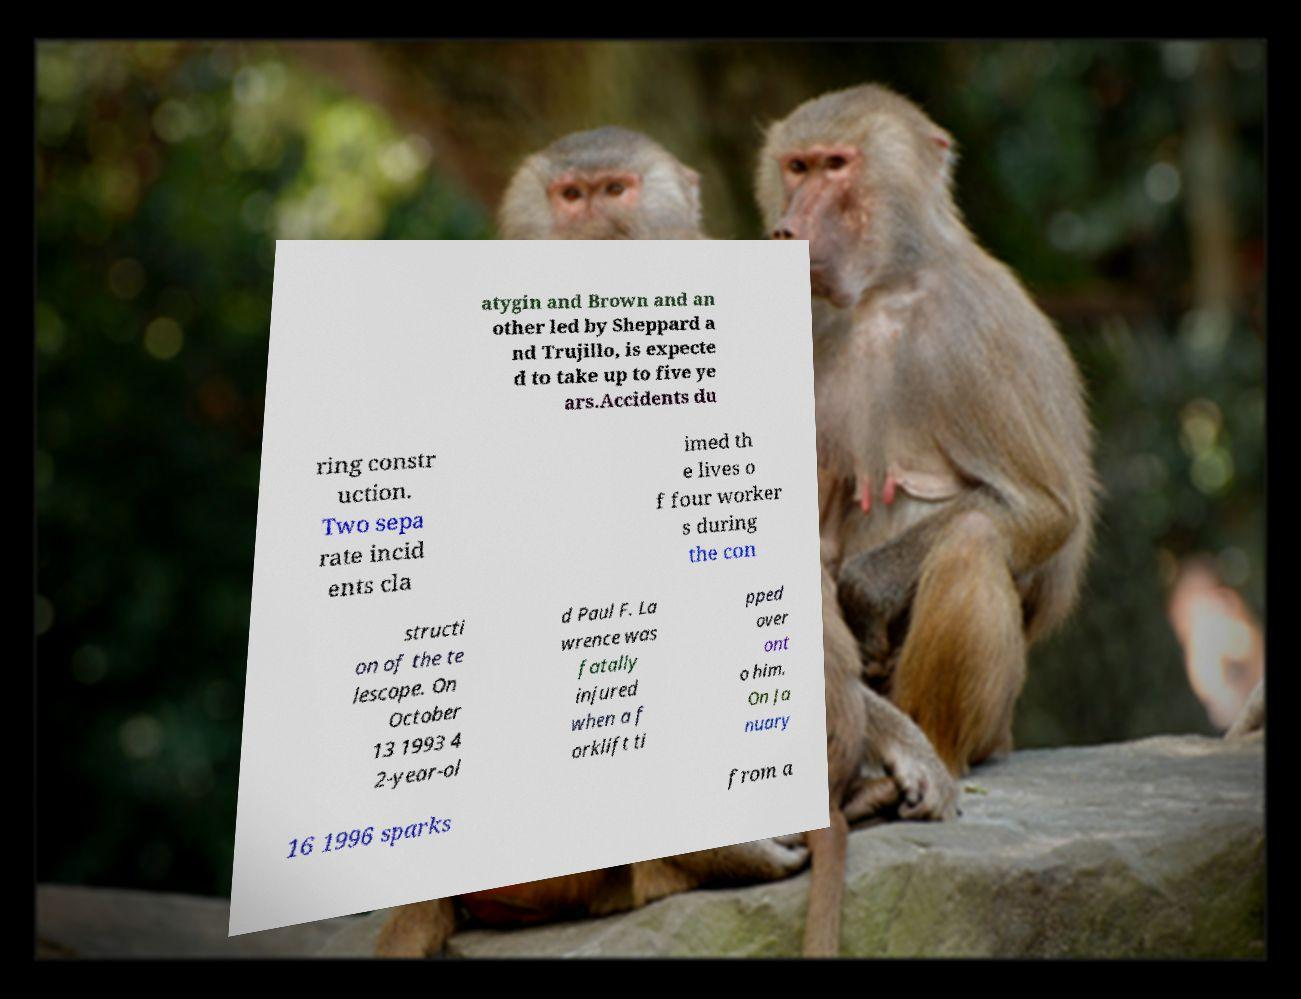I need the written content from this picture converted into text. Can you do that? atygin and Brown and an other led by Sheppard a nd Trujillo, is expecte d to take up to five ye ars.Accidents du ring constr uction. Two sepa rate incid ents cla imed th e lives o f four worker s during the con structi on of the te lescope. On October 13 1993 4 2-year-ol d Paul F. La wrence was fatally injured when a f orklift ti pped over ont o him. On Ja nuary 16 1996 sparks from a 